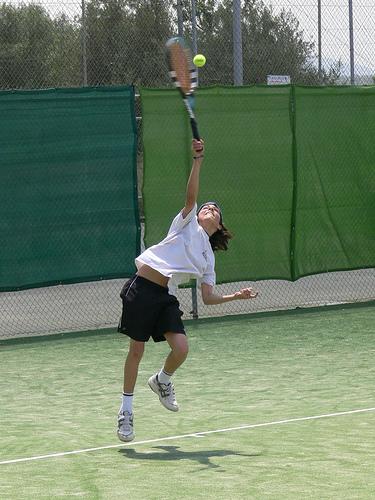How many hands are holding the tennis racket?
Write a very short answer. 1. What is this person holding?
Quick response, please. Tennis racket. Where is the person's shadow?
Short answer required. Below her. 